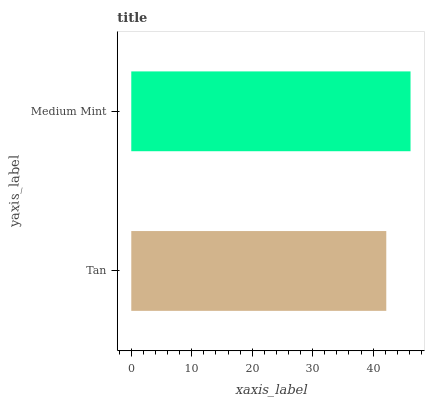Is Tan the minimum?
Answer yes or no. Yes. Is Medium Mint the maximum?
Answer yes or no. Yes. Is Medium Mint the minimum?
Answer yes or no. No. Is Medium Mint greater than Tan?
Answer yes or no. Yes. Is Tan less than Medium Mint?
Answer yes or no. Yes. Is Tan greater than Medium Mint?
Answer yes or no. No. Is Medium Mint less than Tan?
Answer yes or no. No. Is Medium Mint the high median?
Answer yes or no. Yes. Is Tan the low median?
Answer yes or no. Yes. Is Tan the high median?
Answer yes or no. No. Is Medium Mint the low median?
Answer yes or no. No. 